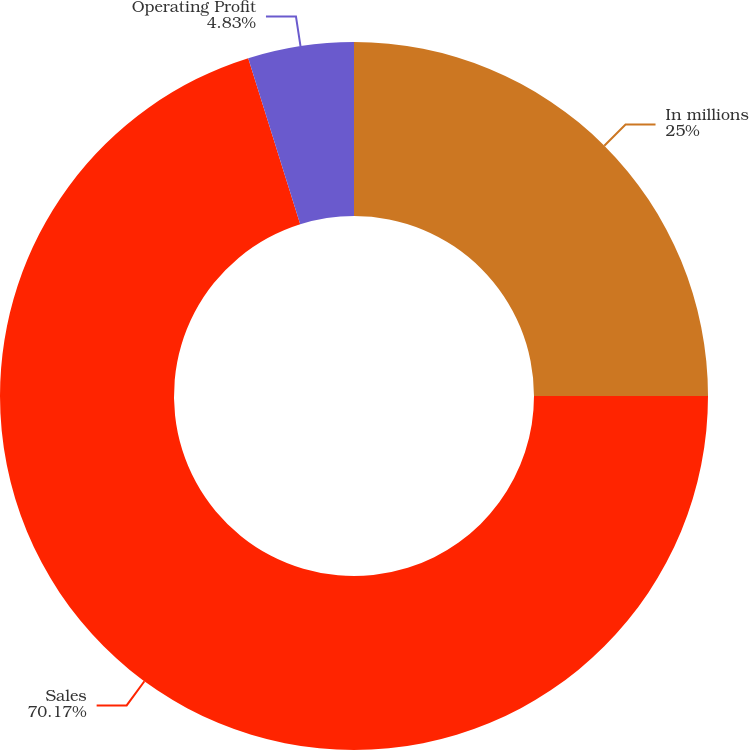Convert chart to OTSL. <chart><loc_0><loc_0><loc_500><loc_500><pie_chart><fcel>In millions<fcel>Sales<fcel>Operating Profit<nl><fcel>25.0%<fcel>70.17%<fcel>4.83%<nl></chart> 